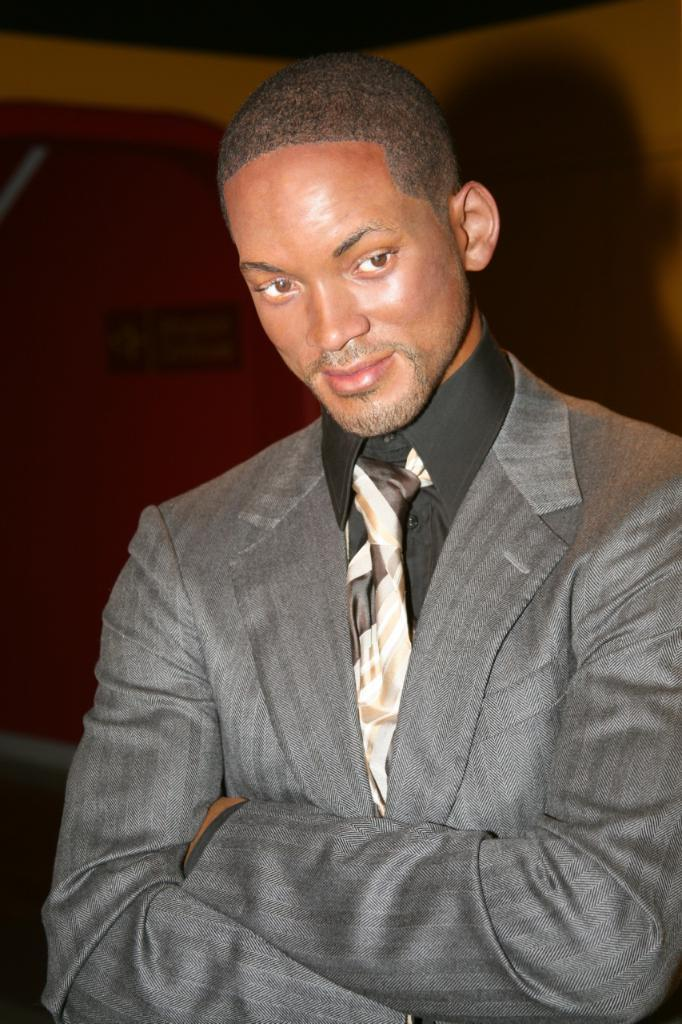What is present in the image? There is a man in the image. How is the man's facial expression in the image? The man is smiling in the image. What type of bird can be seen flying next to the man in the image? There is no bird present in the image; only the man is visible. What type of seat is the man sitting on in the image? There is no seat present in the image; the man is standing. 